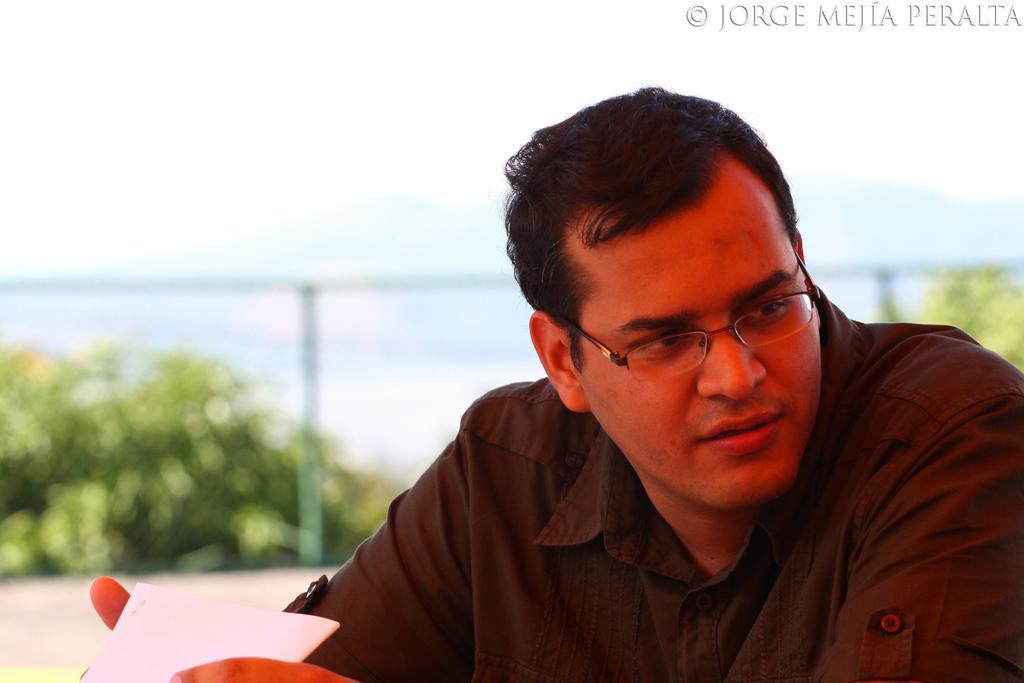In one or two sentences, can you explain what this image depicts? In this image I can see a person wearing brown colored shirt is holding a paper in his hands. I can see he is wearing spectacles. In the background I can see few trees, the metal railing and the sky. 